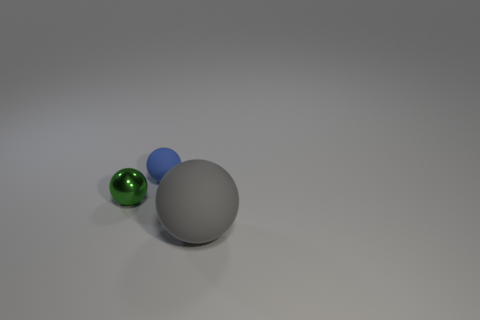How many small things are either matte objects or green rubber things?
Your answer should be compact. 1. How many objects are either matte spheres that are in front of the green metallic thing or small cyan matte spheres?
Give a very brief answer. 1. Is the small matte object the same color as the big sphere?
Offer a very short reply. No. How many other things are there of the same shape as the big object?
Provide a succinct answer. 2. What number of blue things are either rubber balls or shiny spheres?
Keep it short and to the point. 1. What is the color of the sphere that is the same material as the gray thing?
Make the answer very short. Blue. Does the gray ball that is in front of the blue rubber ball have the same material as the object that is to the left of the blue matte object?
Provide a succinct answer. No. What is the ball in front of the small green thing made of?
Your answer should be very brief. Rubber. Do the small object behind the small metal object and the matte thing in front of the blue matte thing have the same shape?
Offer a very short reply. Yes. Are there any green objects?
Your response must be concise. Yes. 